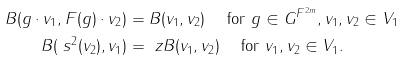Convert formula to latex. <formula><loc_0><loc_0><loc_500><loc_500>B ( g \cdot v _ { 1 } , F ( g ) \cdot v _ { 2 } ) & = B ( v _ { 1 } , v _ { 2 } ) \quad \text { for } g \in G ^ { F ^ { 2 m } } , v _ { 1 } , v _ { 2 } \in V _ { 1 } \\ B ( \ s ^ { 2 } ( v _ { 2 } ) , v _ { 1 } ) & = \ z B ( v _ { 1 } , v _ { 2 } ) \quad \text { for } v _ { 1 } , v _ { 2 } \in V _ { 1 } .</formula> 